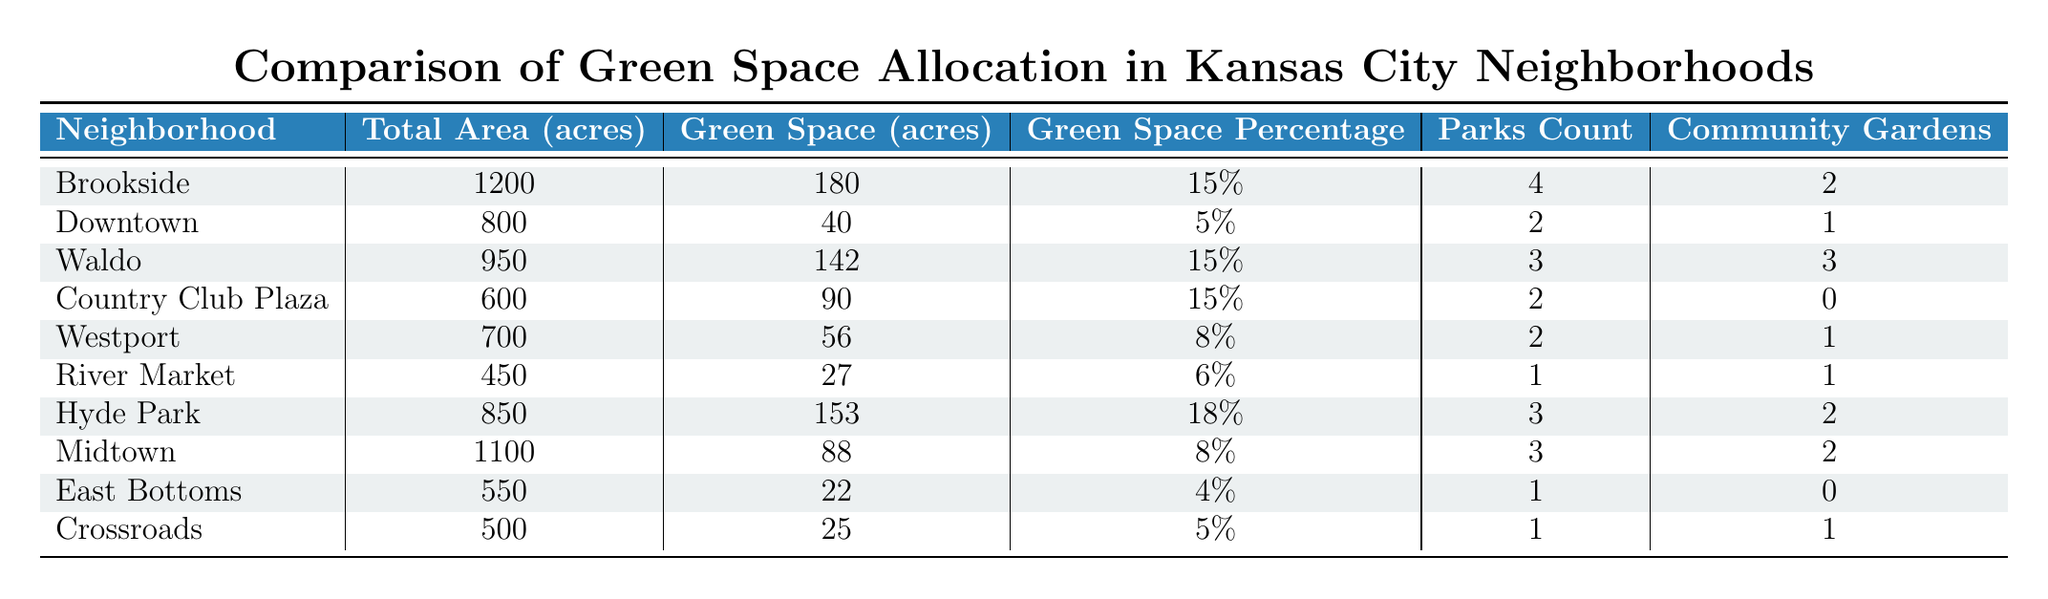What is the total area of the Waldo neighborhood? The table lists the total area for Waldo as 950 acres.
Answer: 950 acres How many parks are there in the Hyde Park neighborhood? According to the table, Hyde Park has 3 parks.
Answer: 3 parks Which neighborhood has the highest percentage of green space? By comparing the "Green Space Percentage" values, Hyde Park has the highest at 18%.
Answer: Hyde Park What is the total green space in the Country Club Plaza and Westport neighborhoods combined? Country Club Plaza has 90 acres of green space, and Westport has 56 acres. Adding these gives 90 + 56 = 146 acres total.
Answer: 146 acres Does Downtown have more parks than East Bottoms? Downtown has 2 parks, while East Bottoms has 1 park. Thus the statement is true.
Answer: Yes What is the average green space percentage across all neighborhoods? To find the average, sum all the percentages: 15 + 5 + 15 + 15 + 8 + 6 + 18 + 8 + 4 + 5 = 105. There are 10 neighborhoods, so the average is 105 / 10 = 10.5%.
Answer: 10.5% Which neighborhood has the least total area? By comparing the values in the "Total Area" column, River Market has the least at 450 acres.
Answer: River Market What is the difference in parks count between Brookside and Waldo? Brookside has 4 parks, and Waldo has 3 parks. The difference is 4 - 3 = 1 park.
Answer: 1 park In which neighborhood is the green space percentage exactly 5%? The table shows that Downtown and Crossroads both have a green space percentage of 5%.
Answer: Downtown and Crossroads Which neighborhood has the most community gardens, and how many are there? The neighborhood with the most community gardens is Waldo, which has 3 community gardens.
Answer: Waldo, 3 gardens 